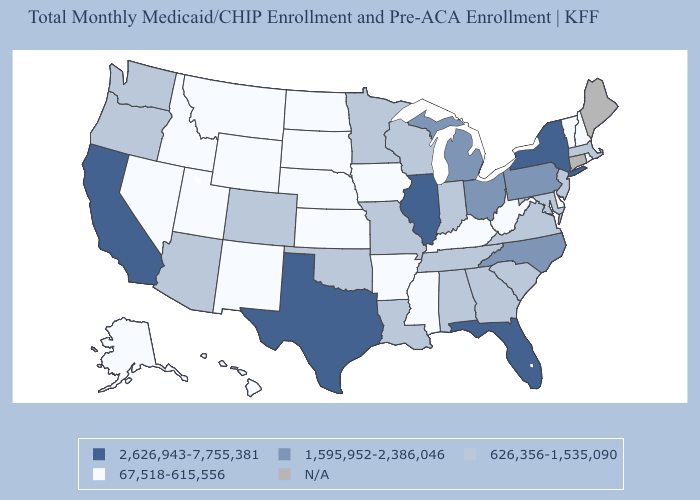What is the value of Wisconsin?
Quick response, please. 626,356-1,535,090. Does New York have the highest value in the Northeast?
Write a very short answer. Yes. Name the states that have a value in the range 1,595,952-2,386,046?
Be succinct. Michigan, North Carolina, Ohio, Pennsylvania. What is the highest value in states that border Massachusetts?
Short answer required. 2,626,943-7,755,381. Among the states that border Tennessee , which have the highest value?
Give a very brief answer. North Carolina. What is the value of Delaware?
Give a very brief answer. 67,518-615,556. What is the lowest value in the USA?
Be succinct. 67,518-615,556. What is the value of Pennsylvania?
Answer briefly. 1,595,952-2,386,046. What is the value of Mississippi?
Concise answer only. 67,518-615,556. Which states hav the highest value in the West?
Concise answer only. California. Among the states that border Wyoming , does Utah have the lowest value?
Answer briefly. Yes. Does Texas have the highest value in the USA?
Concise answer only. Yes. Name the states that have a value in the range 67,518-615,556?
Keep it brief. Alaska, Arkansas, Delaware, Hawaii, Idaho, Iowa, Kansas, Kentucky, Mississippi, Montana, Nebraska, Nevada, New Hampshire, New Mexico, North Dakota, Rhode Island, South Dakota, Utah, Vermont, West Virginia, Wyoming. 